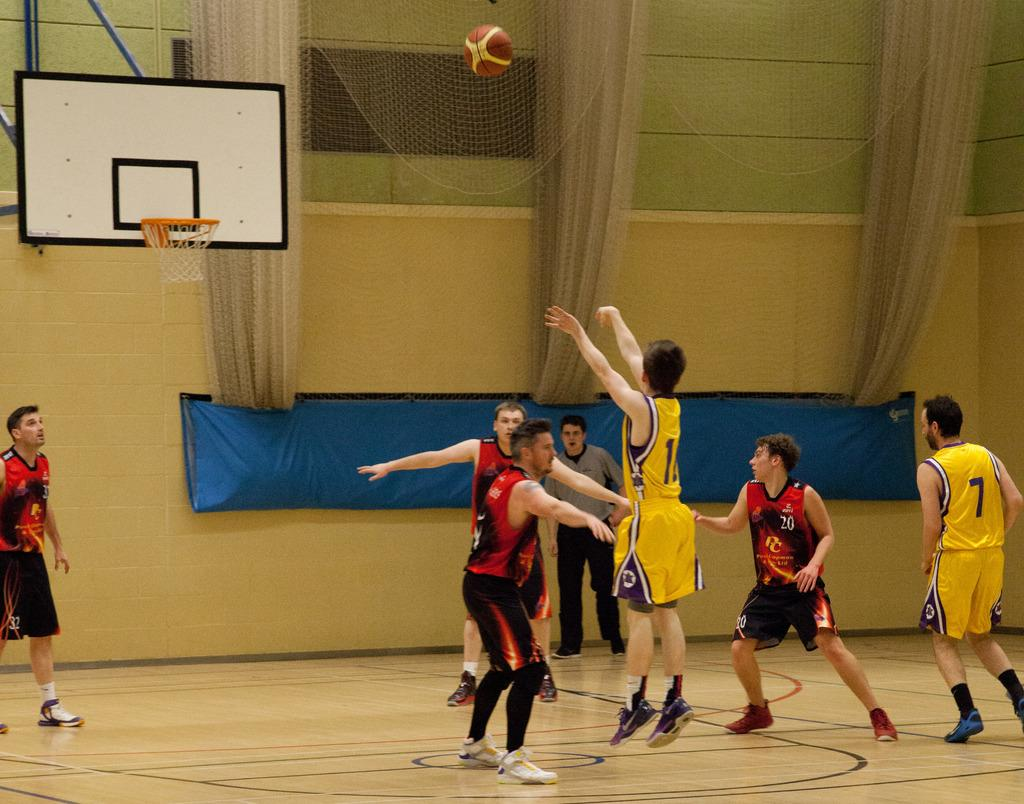<image>
Share a concise interpretation of the image provided. Yellow player 7 watches as his teammate shoots the ball while red player 20 tries to block it. 